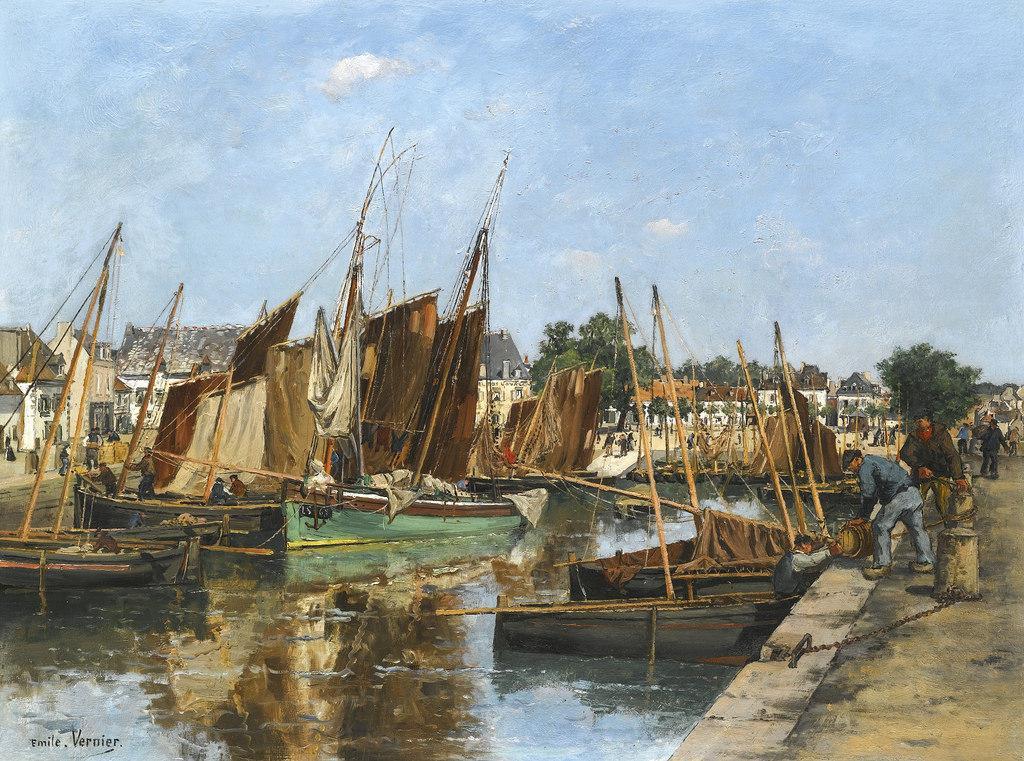Describe this image in one or two sentences. In this image, we can see an art contains some boats floating on the water. There are two persons on the right side of the image wearing clothes. There are building on the left side of the image. In the background of the image, there is a sky. 